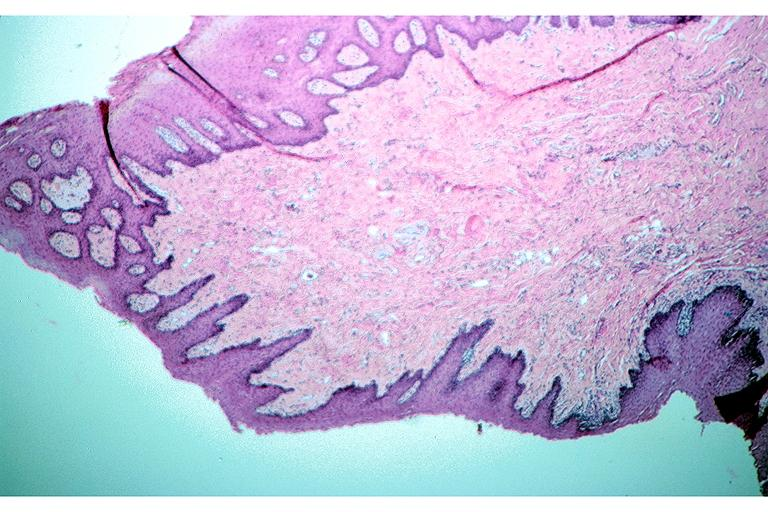where is this?
Answer the question using a single word or phrase. Oral 